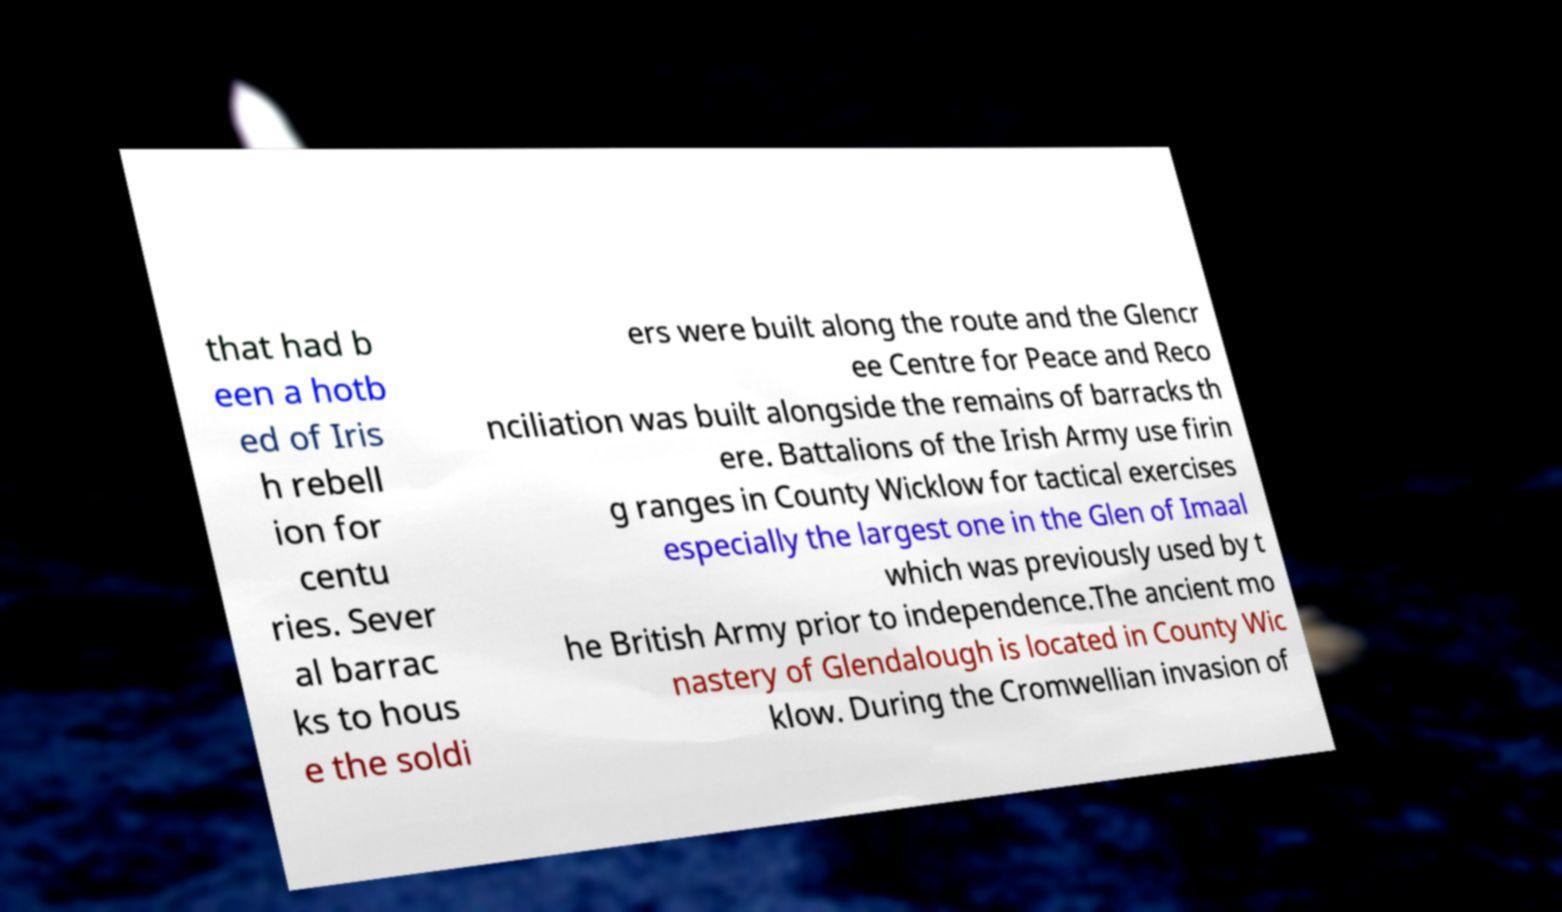What messages or text are displayed in this image? I need them in a readable, typed format. that had b een a hotb ed of Iris h rebell ion for centu ries. Sever al barrac ks to hous e the soldi ers were built along the route and the Glencr ee Centre for Peace and Reco nciliation was built alongside the remains of barracks th ere. Battalions of the Irish Army use firin g ranges in County Wicklow for tactical exercises especially the largest one in the Glen of Imaal which was previously used by t he British Army prior to independence.The ancient mo nastery of Glendalough is located in County Wic klow. During the Cromwellian invasion of 